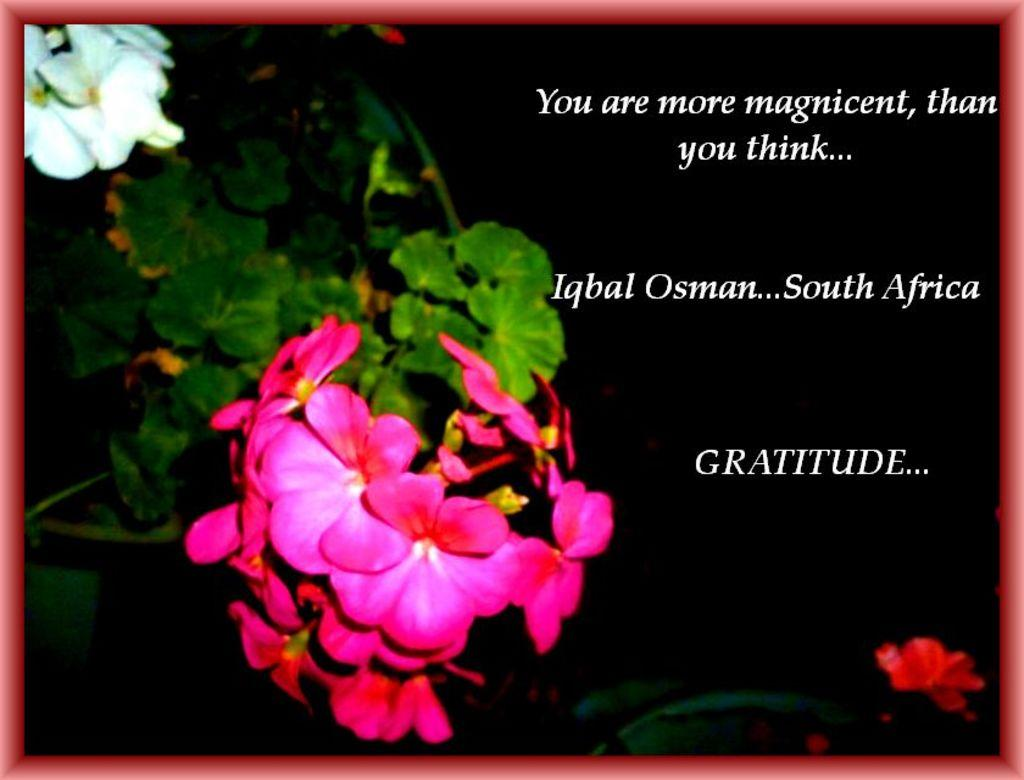What colors are the flowers in the image? The flowers in the image are pink, red, and white. What are the main parts of the flowers? The flowers have stems and leaves. Where is the text located in the image? The text is written on the right side of the image. What is the income of the flowers in the image? The flowers in the image do not have an income, as they are not living beings capable of earning money. 